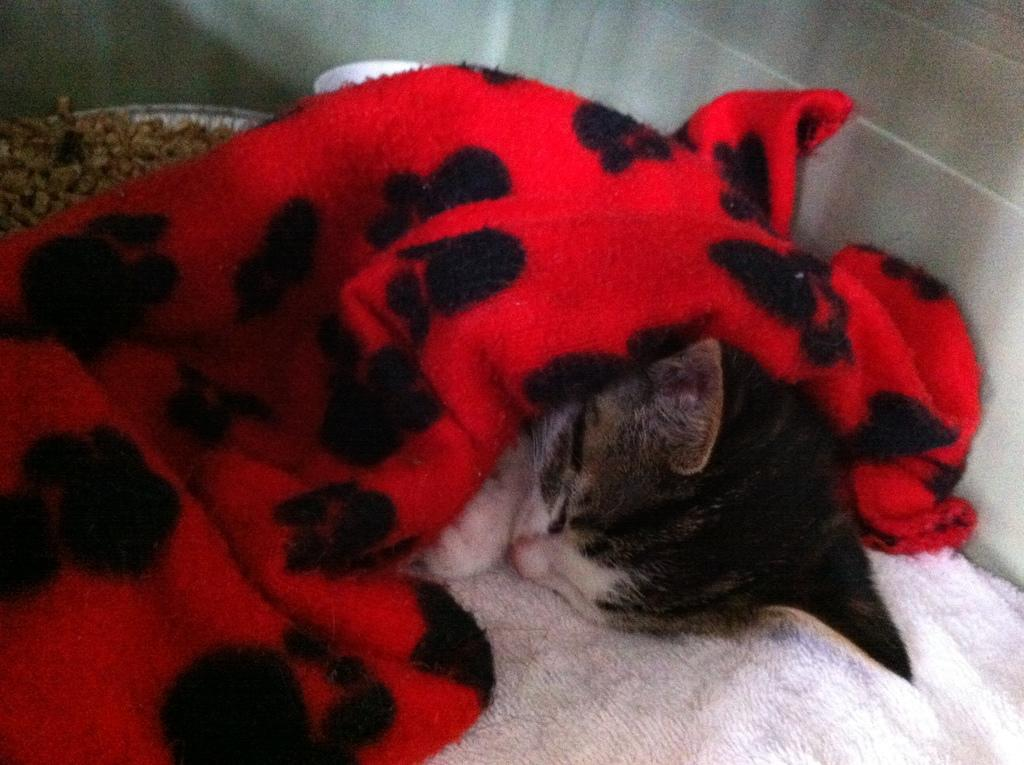What animal can be seen in the image? There is a cat in the image. Where is the cat located in the image? The cat is sleeping on a couch. What is covering the cat in the image? There is a cloth on the cat. What type of medical process is the cat undergoing in the image? There is no indication of a medical process in the image; the cat is simply sleeping on a couch with a cloth on it. 